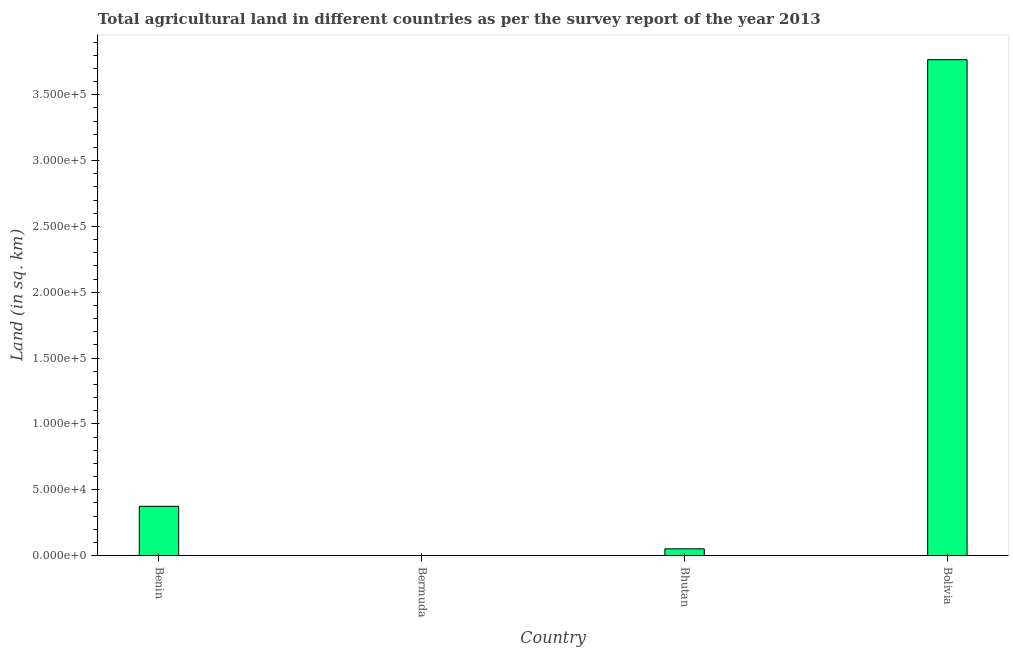What is the title of the graph?
Your response must be concise. Total agricultural land in different countries as per the survey report of the year 2013. What is the label or title of the Y-axis?
Your answer should be compact. Land (in sq. km). Across all countries, what is the maximum agricultural land?
Your response must be concise. 3.77e+05. Across all countries, what is the minimum agricultural land?
Provide a short and direct response. 3. In which country was the agricultural land maximum?
Give a very brief answer. Bolivia. In which country was the agricultural land minimum?
Ensure brevity in your answer.  Bermuda. What is the sum of the agricultural land?
Give a very brief answer. 4.19e+05. What is the difference between the agricultural land in Bhutan and Bolivia?
Keep it short and to the point. -3.72e+05. What is the average agricultural land per country?
Give a very brief answer. 1.05e+05. What is the median agricultural land?
Make the answer very short. 2.13e+04. In how many countries, is the agricultural land greater than 300000 sq. km?
Your answer should be compact. 1. What is the ratio of the agricultural land in Benin to that in Bolivia?
Your answer should be very brief. 0.1. Is the agricultural land in Benin less than that in Bolivia?
Make the answer very short. Yes. Is the difference between the agricultural land in Bhutan and Bolivia greater than the difference between any two countries?
Provide a succinct answer. No. What is the difference between the highest and the second highest agricultural land?
Give a very brief answer. 3.39e+05. What is the difference between the highest and the lowest agricultural land?
Keep it short and to the point. 3.77e+05. How many bars are there?
Your answer should be compact. 4. How many countries are there in the graph?
Provide a short and direct response. 4. Are the values on the major ticks of Y-axis written in scientific E-notation?
Provide a succinct answer. Yes. What is the Land (in sq. km) in Benin?
Provide a short and direct response. 3.75e+04. What is the Land (in sq. km) of Bermuda?
Offer a very short reply. 3. What is the Land (in sq. km) of Bhutan?
Make the answer very short. 5196. What is the Land (in sq. km) in Bolivia?
Offer a terse response. 3.77e+05. What is the difference between the Land (in sq. km) in Benin and Bermuda?
Your response must be concise. 3.75e+04. What is the difference between the Land (in sq. km) in Benin and Bhutan?
Your answer should be compact. 3.23e+04. What is the difference between the Land (in sq. km) in Benin and Bolivia?
Keep it short and to the point. -3.39e+05. What is the difference between the Land (in sq. km) in Bermuda and Bhutan?
Offer a terse response. -5193. What is the difference between the Land (in sq. km) in Bermuda and Bolivia?
Your answer should be compact. -3.77e+05. What is the difference between the Land (in sq. km) in Bhutan and Bolivia?
Your answer should be compact. -3.72e+05. What is the ratio of the Land (in sq. km) in Benin to that in Bermuda?
Ensure brevity in your answer.  1.25e+04. What is the ratio of the Land (in sq. km) in Benin to that in Bhutan?
Ensure brevity in your answer.  7.22. What is the ratio of the Land (in sq. km) in Benin to that in Bolivia?
Provide a succinct answer. 0.1. What is the ratio of the Land (in sq. km) in Bermuda to that in Bolivia?
Your response must be concise. 0. What is the ratio of the Land (in sq. km) in Bhutan to that in Bolivia?
Keep it short and to the point. 0.01. 